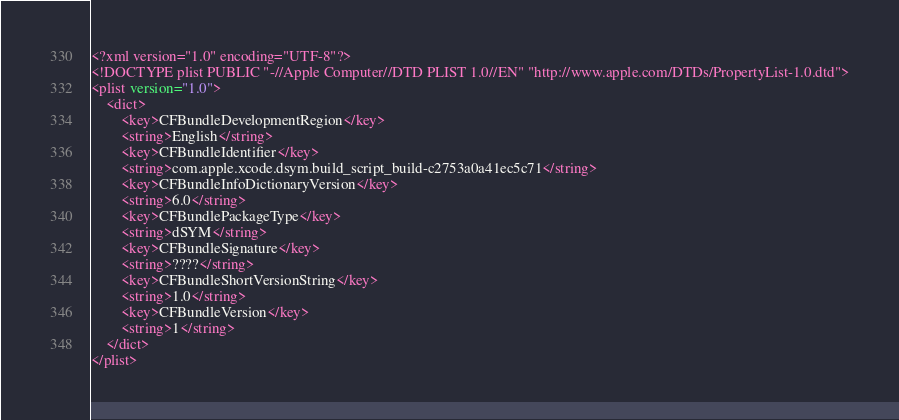<code> <loc_0><loc_0><loc_500><loc_500><_XML_><?xml version="1.0" encoding="UTF-8"?>
<!DOCTYPE plist PUBLIC "-//Apple Computer//DTD PLIST 1.0//EN" "http://www.apple.com/DTDs/PropertyList-1.0.dtd">
<plist version="1.0">
	<dict>
		<key>CFBundleDevelopmentRegion</key>
		<string>English</string>
		<key>CFBundleIdentifier</key>
		<string>com.apple.xcode.dsym.build_script_build-c2753a0a41ec5c71</string>
		<key>CFBundleInfoDictionaryVersion</key>
		<string>6.0</string>
		<key>CFBundlePackageType</key>
		<string>dSYM</string>
		<key>CFBundleSignature</key>
		<string>????</string>
		<key>CFBundleShortVersionString</key>
		<string>1.0</string>
		<key>CFBundleVersion</key>
		<string>1</string>
	</dict>
</plist>
</code> 